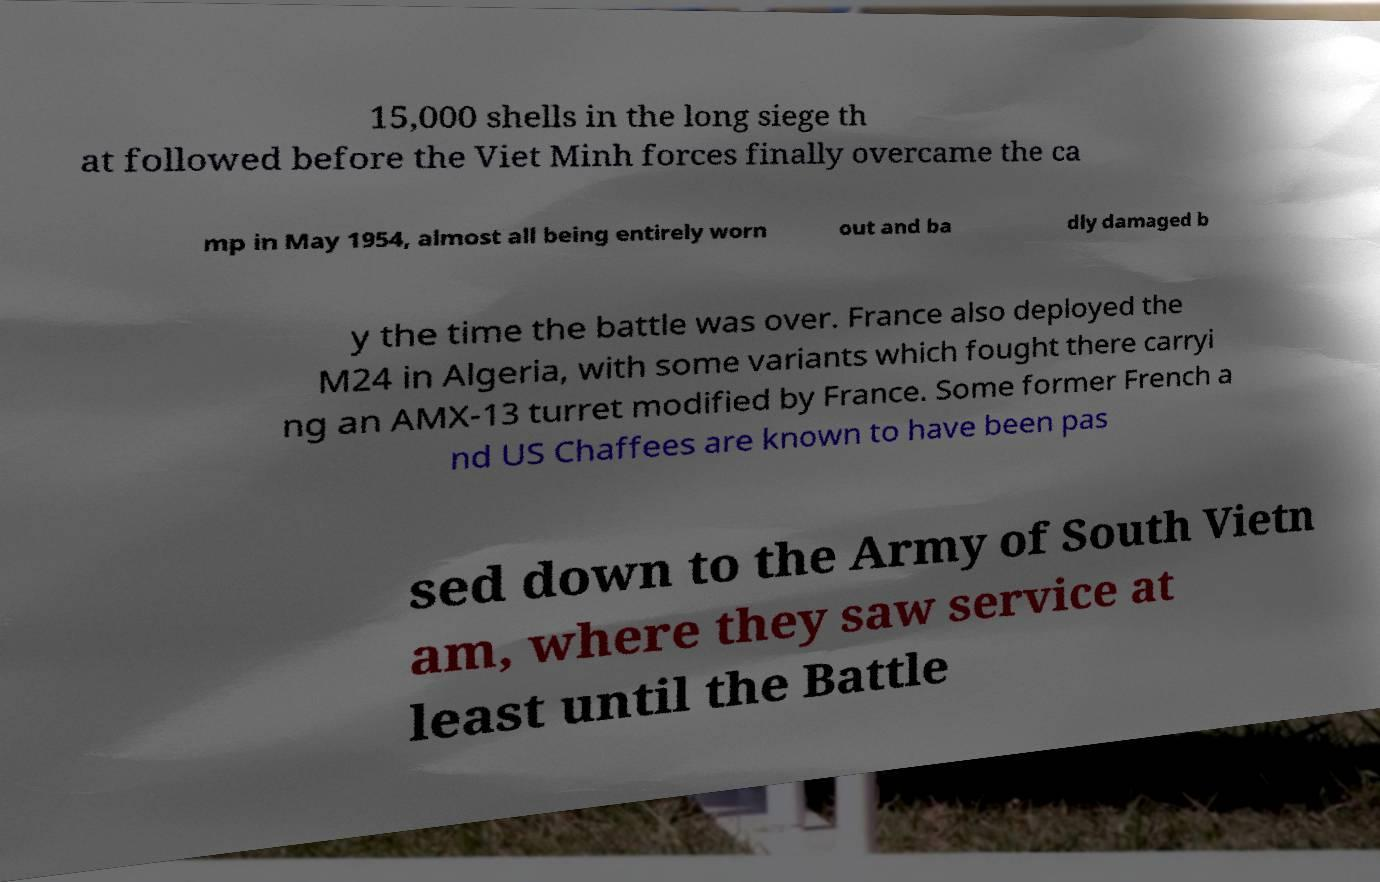Can you read and provide the text displayed in the image?This photo seems to have some interesting text. Can you extract and type it out for me? 15,000 shells in the long siege th at followed before the Viet Minh forces finally overcame the ca mp in May 1954, almost all being entirely worn out and ba dly damaged b y the time the battle was over. France also deployed the M24 in Algeria, with some variants which fought there carryi ng an AMX-13 turret modified by France. Some former French a nd US Chaffees are known to have been pas sed down to the Army of South Vietn am, where they saw service at least until the Battle 